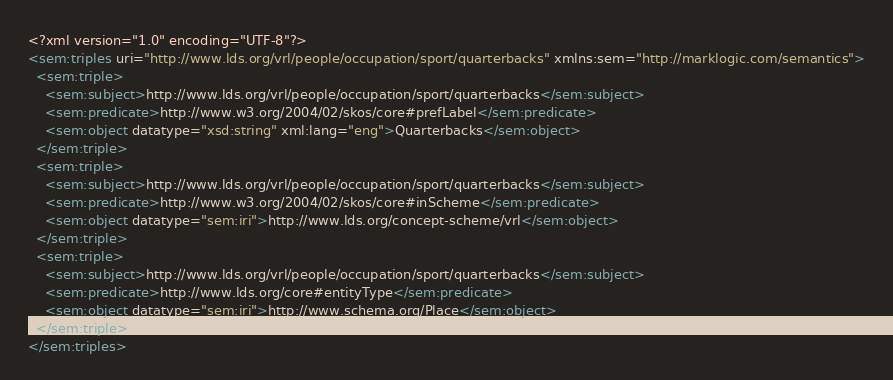Convert code to text. <code><loc_0><loc_0><loc_500><loc_500><_XML_><?xml version="1.0" encoding="UTF-8"?>
<sem:triples uri="http://www.lds.org/vrl/people/occupation/sport/quarterbacks" xmlns:sem="http://marklogic.com/semantics">
  <sem:triple>
    <sem:subject>http://www.lds.org/vrl/people/occupation/sport/quarterbacks</sem:subject>
    <sem:predicate>http://www.w3.org/2004/02/skos/core#prefLabel</sem:predicate>
    <sem:object datatype="xsd:string" xml:lang="eng">Quarterbacks</sem:object>
  </sem:triple>
  <sem:triple>
    <sem:subject>http://www.lds.org/vrl/people/occupation/sport/quarterbacks</sem:subject>
    <sem:predicate>http://www.w3.org/2004/02/skos/core#inScheme</sem:predicate>
    <sem:object datatype="sem:iri">http://www.lds.org/concept-scheme/vrl</sem:object>
  </sem:triple>
  <sem:triple>
    <sem:subject>http://www.lds.org/vrl/people/occupation/sport/quarterbacks</sem:subject>
    <sem:predicate>http://www.lds.org/core#entityType</sem:predicate>
    <sem:object datatype="sem:iri">http://www.schema.org/Place</sem:object>
  </sem:triple>
</sem:triples>
</code> 